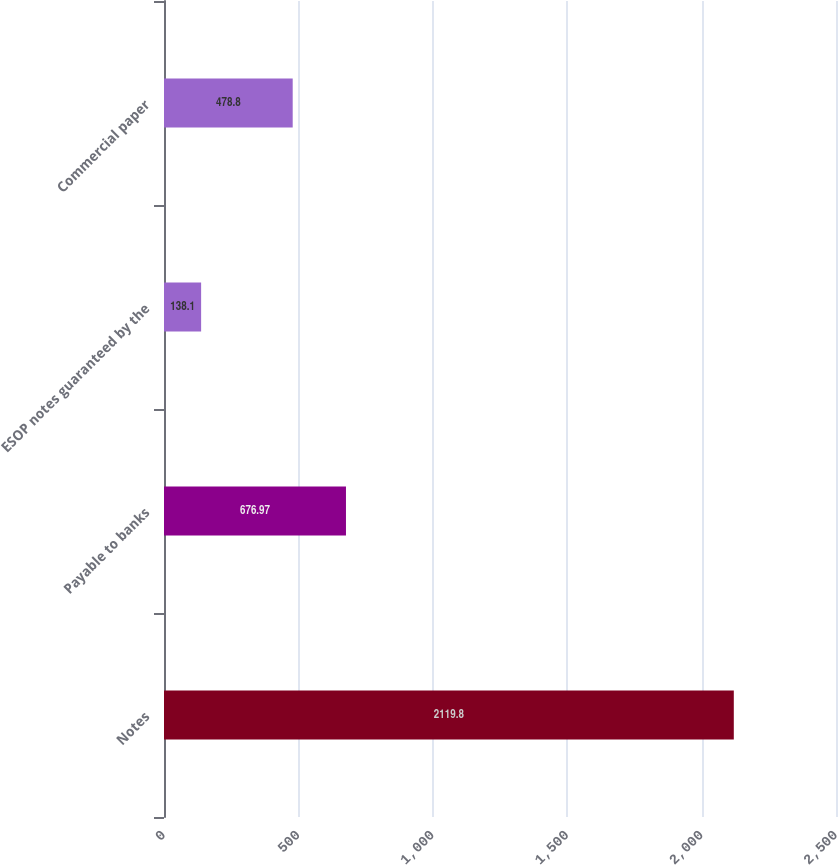Convert chart to OTSL. <chart><loc_0><loc_0><loc_500><loc_500><bar_chart><fcel>Notes<fcel>Payable to banks<fcel>ESOP notes guaranteed by the<fcel>Commercial paper<nl><fcel>2119.8<fcel>676.97<fcel>138.1<fcel>478.8<nl></chart> 